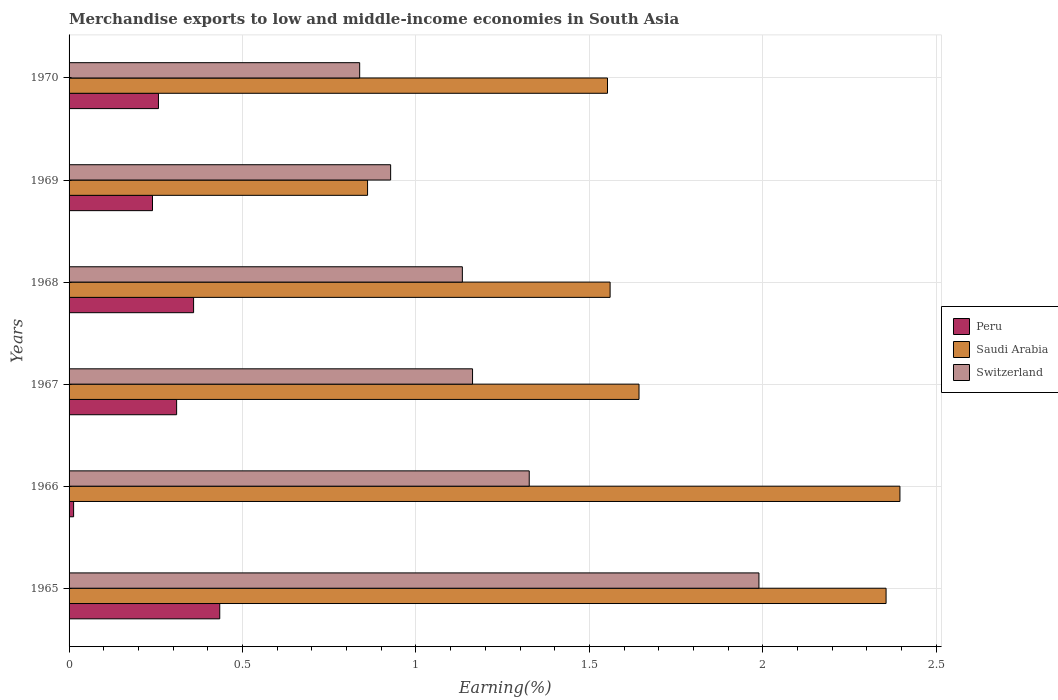How many groups of bars are there?
Make the answer very short. 6. How many bars are there on the 5th tick from the top?
Ensure brevity in your answer.  3. What is the label of the 2nd group of bars from the top?
Offer a terse response. 1969. What is the percentage of amount earned from merchandise exports in Switzerland in 1970?
Ensure brevity in your answer.  0.84. Across all years, what is the maximum percentage of amount earned from merchandise exports in Saudi Arabia?
Offer a terse response. 2.4. Across all years, what is the minimum percentage of amount earned from merchandise exports in Peru?
Your answer should be very brief. 0.01. In which year was the percentage of amount earned from merchandise exports in Peru maximum?
Your response must be concise. 1965. In which year was the percentage of amount earned from merchandise exports in Peru minimum?
Offer a very short reply. 1966. What is the total percentage of amount earned from merchandise exports in Saudi Arabia in the graph?
Make the answer very short. 10.37. What is the difference between the percentage of amount earned from merchandise exports in Peru in 1965 and that in 1969?
Provide a short and direct response. 0.19. What is the difference between the percentage of amount earned from merchandise exports in Peru in 1970 and the percentage of amount earned from merchandise exports in Saudi Arabia in 1967?
Offer a terse response. -1.39. What is the average percentage of amount earned from merchandise exports in Saudi Arabia per year?
Give a very brief answer. 1.73. In the year 1967, what is the difference between the percentage of amount earned from merchandise exports in Saudi Arabia and percentage of amount earned from merchandise exports in Peru?
Keep it short and to the point. 1.33. What is the ratio of the percentage of amount earned from merchandise exports in Switzerland in 1967 to that in 1969?
Offer a very short reply. 1.25. Is the difference between the percentage of amount earned from merchandise exports in Saudi Arabia in 1968 and 1970 greater than the difference between the percentage of amount earned from merchandise exports in Peru in 1968 and 1970?
Ensure brevity in your answer.  No. What is the difference between the highest and the second highest percentage of amount earned from merchandise exports in Switzerland?
Offer a very short reply. 0.66. What is the difference between the highest and the lowest percentage of amount earned from merchandise exports in Switzerland?
Provide a short and direct response. 1.15. Is the sum of the percentage of amount earned from merchandise exports in Switzerland in 1968 and 1969 greater than the maximum percentage of amount earned from merchandise exports in Peru across all years?
Ensure brevity in your answer.  Yes. What does the 3rd bar from the top in 1969 represents?
Your answer should be very brief. Peru. Are all the bars in the graph horizontal?
Keep it short and to the point. Yes. How many years are there in the graph?
Offer a terse response. 6. Are the values on the major ticks of X-axis written in scientific E-notation?
Offer a terse response. No. How many legend labels are there?
Your answer should be compact. 3. How are the legend labels stacked?
Make the answer very short. Vertical. What is the title of the graph?
Provide a short and direct response. Merchandise exports to low and middle-income economies in South Asia. What is the label or title of the X-axis?
Give a very brief answer. Earning(%). What is the Earning(%) of Peru in 1965?
Your answer should be very brief. 0.43. What is the Earning(%) in Saudi Arabia in 1965?
Offer a very short reply. 2.36. What is the Earning(%) in Switzerland in 1965?
Make the answer very short. 1.99. What is the Earning(%) in Peru in 1966?
Provide a succinct answer. 0.01. What is the Earning(%) in Saudi Arabia in 1966?
Provide a succinct answer. 2.4. What is the Earning(%) in Switzerland in 1966?
Ensure brevity in your answer.  1.33. What is the Earning(%) of Peru in 1967?
Offer a very short reply. 0.31. What is the Earning(%) of Saudi Arabia in 1967?
Make the answer very short. 1.64. What is the Earning(%) of Switzerland in 1967?
Keep it short and to the point. 1.16. What is the Earning(%) of Peru in 1968?
Give a very brief answer. 0.36. What is the Earning(%) in Saudi Arabia in 1968?
Provide a short and direct response. 1.56. What is the Earning(%) of Switzerland in 1968?
Offer a very short reply. 1.13. What is the Earning(%) of Peru in 1969?
Keep it short and to the point. 0.24. What is the Earning(%) of Saudi Arabia in 1969?
Your response must be concise. 0.86. What is the Earning(%) of Switzerland in 1969?
Give a very brief answer. 0.93. What is the Earning(%) in Peru in 1970?
Your answer should be very brief. 0.26. What is the Earning(%) of Saudi Arabia in 1970?
Your answer should be very brief. 1.55. What is the Earning(%) of Switzerland in 1970?
Give a very brief answer. 0.84. Across all years, what is the maximum Earning(%) of Peru?
Your answer should be very brief. 0.43. Across all years, what is the maximum Earning(%) in Saudi Arabia?
Offer a terse response. 2.4. Across all years, what is the maximum Earning(%) in Switzerland?
Give a very brief answer. 1.99. Across all years, what is the minimum Earning(%) of Peru?
Your answer should be compact. 0.01. Across all years, what is the minimum Earning(%) in Saudi Arabia?
Ensure brevity in your answer.  0.86. Across all years, what is the minimum Earning(%) of Switzerland?
Offer a very short reply. 0.84. What is the total Earning(%) in Peru in the graph?
Your answer should be very brief. 1.61. What is the total Earning(%) of Saudi Arabia in the graph?
Ensure brevity in your answer.  10.37. What is the total Earning(%) in Switzerland in the graph?
Provide a succinct answer. 7.38. What is the difference between the Earning(%) in Peru in 1965 and that in 1966?
Make the answer very short. 0.42. What is the difference between the Earning(%) in Saudi Arabia in 1965 and that in 1966?
Offer a terse response. -0.04. What is the difference between the Earning(%) of Switzerland in 1965 and that in 1966?
Your response must be concise. 0.66. What is the difference between the Earning(%) of Peru in 1965 and that in 1967?
Your response must be concise. 0.12. What is the difference between the Earning(%) of Saudi Arabia in 1965 and that in 1967?
Give a very brief answer. 0.71. What is the difference between the Earning(%) in Switzerland in 1965 and that in 1967?
Ensure brevity in your answer.  0.83. What is the difference between the Earning(%) of Peru in 1965 and that in 1968?
Provide a succinct answer. 0.08. What is the difference between the Earning(%) in Saudi Arabia in 1965 and that in 1968?
Offer a very short reply. 0.8. What is the difference between the Earning(%) in Switzerland in 1965 and that in 1968?
Your answer should be very brief. 0.85. What is the difference between the Earning(%) in Peru in 1965 and that in 1969?
Offer a terse response. 0.19. What is the difference between the Earning(%) of Saudi Arabia in 1965 and that in 1969?
Provide a short and direct response. 1.49. What is the difference between the Earning(%) of Switzerland in 1965 and that in 1969?
Make the answer very short. 1.06. What is the difference between the Earning(%) of Peru in 1965 and that in 1970?
Your answer should be compact. 0.18. What is the difference between the Earning(%) in Saudi Arabia in 1965 and that in 1970?
Make the answer very short. 0.8. What is the difference between the Earning(%) of Switzerland in 1965 and that in 1970?
Offer a terse response. 1.15. What is the difference between the Earning(%) in Peru in 1966 and that in 1967?
Ensure brevity in your answer.  -0.3. What is the difference between the Earning(%) in Saudi Arabia in 1966 and that in 1967?
Offer a terse response. 0.75. What is the difference between the Earning(%) in Switzerland in 1966 and that in 1967?
Offer a terse response. 0.16. What is the difference between the Earning(%) in Peru in 1966 and that in 1968?
Make the answer very short. -0.35. What is the difference between the Earning(%) in Saudi Arabia in 1966 and that in 1968?
Make the answer very short. 0.84. What is the difference between the Earning(%) in Switzerland in 1966 and that in 1968?
Provide a short and direct response. 0.19. What is the difference between the Earning(%) in Peru in 1966 and that in 1969?
Give a very brief answer. -0.23. What is the difference between the Earning(%) of Saudi Arabia in 1966 and that in 1969?
Offer a very short reply. 1.53. What is the difference between the Earning(%) in Switzerland in 1966 and that in 1969?
Give a very brief answer. 0.4. What is the difference between the Earning(%) in Peru in 1966 and that in 1970?
Offer a terse response. -0.24. What is the difference between the Earning(%) in Saudi Arabia in 1966 and that in 1970?
Make the answer very short. 0.84. What is the difference between the Earning(%) of Switzerland in 1966 and that in 1970?
Keep it short and to the point. 0.49. What is the difference between the Earning(%) of Peru in 1967 and that in 1968?
Your response must be concise. -0.05. What is the difference between the Earning(%) of Saudi Arabia in 1967 and that in 1968?
Provide a succinct answer. 0.08. What is the difference between the Earning(%) in Switzerland in 1967 and that in 1968?
Keep it short and to the point. 0.03. What is the difference between the Earning(%) of Peru in 1967 and that in 1969?
Your response must be concise. 0.07. What is the difference between the Earning(%) of Saudi Arabia in 1967 and that in 1969?
Offer a terse response. 0.78. What is the difference between the Earning(%) in Switzerland in 1967 and that in 1969?
Give a very brief answer. 0.24. What is the difference between the Earning(%) of Peru in 1967 and that in 1970?
Provide a succinct answer. 0.05. What is the difference between the Earning(%) in Saudi Arabia in 1967 and that in 1970?
Offer a very short reply. 0.09. What is the difference between the Earning(%) of Switzerland in 1967 and that in 1970?
Your answer should be very brief. 0.33. What is the difference between the Earning(%) in Peru in 1968 and that in 1969?
Provide a short and direct response. 0.12. What is the difference between the Earning(%) of Saudi Arabia in 1968 and that in 1969?
Your response must be concise. 0.7. What is the difference between the Earning(%) in Switzerland in 1968 and that in 1969?
Your response must be concise. 0.21. What is the difference between the Earning(%) in Peru in 1968 and that in 1970?
Provide a short and direct response. 0.1. What is the difference between the Earning(%) of Saudi Arabia in 1968 and that in 1970?
Make the answer very short. 0.01. What is the difference between the Earning(%) of Switzerland in 1968 and that in 1970?
Give a very brief answer. 0.3. What is the difference between the Earning(%) of Peru in 1969 and that in 1970?
Ensure brevity in your answer.  -0.02. What is the difference between the Earning(%) in Saudi Arabia in 1969 and that in 1970?
Provide a short and direct response. -0.69. What is the difference between the Earning(%) in Switzerland in 1969 and that in 1970?
Provide a short and direct response. 0.09. What is the difference between the Earning(%) in Peru in 1965 and the Earning(%) in Saudi Arabia in 1966?
Give a very brief answer. -1.96. What is the difference between the Earning(%) in Peru in 1965 and the Earning(%) in Switzerland in 1966?
Offer a terse response. -0.89. What is the difference between the Earning(%) of Saudi Arabia in 1965 and the Earning(%) of Switzerland in 1966?
Offer a very short reply. 1.03. What is the difference between the Earning(%) of Peru in 1965 and the Earning(%) of Saudi Arabia in 1967?
Make the answer very short. -1.21. What is the difference between the Earning(%) of Peru in 1965 and the Earning(%) of Switzerland in 1967?
Give a very brief answer. -0.73. What is the difference between the Earning(%) of Saudi Arabia in 1965 and the Earning(%) of Switzerland in 1967?
Make the answer very short. 1.19. What is the difference between the Earning(%) in Peru in 1965 and the Earning(%) in Saudi Arabia in 1968?
Your answer should be very brief. -1.13. What is the difference between the Earning(%) of Peru in 1965 and the Earning(%) of Switzerland in 1968?
Offer a very short reply. -0.7. What is the difference between the Earning(%) in Saudi Arabia in 1965 and the Earning(%) in Switzerland in 1968?
Offer a terse response. 1.22. What is the difference between the Earning(%) in Peru in 1965 and the Earning(%) in Saudi Arabia in 1969?
Keep it short and to the point. -0.43. What is the difference between the Earning(%) in Peru in 1965 and the Earning(%) in Switzerland in 1969?
Your response must be concise. -0.49. What is the difference between the Earning(%) in Saudi Arabia in 1965 and the Earning(%) in Switzerland in 1969?
Your response must be concise. 1.43. What is the difference between the Earning(%) in Peru in 1965 and the Earning(%) in Saudi Arabia in 1970?
Provide a short and direct response. -1.12. What is the difference between the Earning(%) in Peru in 1965 and the Earning(%) in Switzerland in 1970?
Give a very brief answer. -0.4. What is the difference between the Earning(%) of Saudi Arabia in 1965 and the Earning(%) of Switzerland in 1970?
Provide a short and direct response. 1.52. What is the difference between the Earning(%) of Peru in 1966 and the Earning(%) of Saudi Arabia in 1967?
Provide a short and direct response. -1.63. What is the difference between the Earning(%) in Peru in 1966 and the Earning(%) in Switzerland in 1967?
Make the answer very short. -1.15. What is the difference between the Earning(%) in Saudi Arabia in 1966 and the Earning(%) in Switzerland in 1967?
Your response must be concise. 1.23. What is the difference between the Earning(%) in Peru in 1966 and the Earning(%) in Saudi Arabia in 1968?
Offer a very short reply. -1.55. What is the difference between the Earning(%) in Peru in 1966 and the Earning(%) in Switzerland in 1968?
Provide a succinct answer. -1.12. What is the difference between the Earning(%) of Saudi Arabia in 1966 and the Earning(%) of Switzerland in 1968?
Offer a terse response. 1.26. What is the difference between the Earning(%) in Peru in 1966 and the Earning(%) in Saudi Arabia in 1969?
Offer a very short reply. -0.85. What is the difference between the Earning(%) in Peru in 1966 and the Earning(%) in Switzerland in 1969?
Offer a terse response. -0.91. What is the difference between the Earning(%) of Saudi Arabia in 1966 and the Earning(%) of Switzerland in 1969?
Give a very brief answer. 1.47. What is the difference between the Earning(%) of Peru in 1966 and the Earning(%) of Saudi Arabia in 1970?
Offer a terse response. -1.54. What is the difference between the Earning(%) in Peru in 1966 and the Earning(%) in Switzerland in 1970?
Ensure brevity in your answer.  -0.82. What is the difference between the Earning(%) in Saudi Arabia in 1966 and the Earning(%) in Switzerland in 1970?
Your response must be concise. 1.56. What is the difference between the Earning(%) of Peru in 1967 and the Earning(%) of Saudi Arabia in 1968?
Keep it short and to the point. -1.25. What is the difference between the Earning(%) in Peru in 1967 and the Earning(%) in Switzerland in 1968?
Your response must be concise. -0.82. What is the difference between the Earning(%) in Saudi Arabia in 1967 and the Earning(%) in Switzerland in 1968?
Provide a short and direct response. 0.51. What is the difference between the Earning(%) in Peru in 1967 and the Earning(%) in Saudi Arabia in 1969?
Provide a succinct answer. -0.55. What is the difference between the Earning(%) in Peru in 1967 and the Earning(%) in Switzerland in 1969?
Your answer should be very brief. -0.62. What is the difference between the Earning(%) in Saudi Arabia in 1967 and the Earning(%) in Switzerland in 1969?
Your answer should be very brief. 0.72. What is the difference between the Earning(%) in Peru in 1967 and the Earning(%) in Saudi Arabia in 1970?
Provide a succinct answer. -1.24. What is the difference between the Earning(%) of Peru in 1967 and the Earning(%) of Switzerland in 1970?
Give a very brief answer. -0.53. What is the difference between the Earning(%) in Saudi Arabia in 1967 and the Earning(%) in Switzerland in 1970?
Ensure brevity in your answer.  0.81. What is the difference between the Earning(%) in Peru in 1968 and the Earning(%) in Saudi Arabia in 1969?
Provide a succinct answer. -0.5. What is the difference between the Earning(%) of Peru in 1968 and the Earning(%) of Switzerland in 1969?
Your answer should be compact. -0.57. What is the difference between the Earning(%) of Saudi Arabia in 1968 and the Earning(%) of Switzerland in 1969?
Provide a short and direct response. 0.63. What is the difference between the Earning(%) in Peru in 1968 and the Earning(%) in Saudi Arabia in 1970?
Your answer should be compact. -1.19. What is the difference between the Earning(%) of Peru in 1968 and the Earning(%) of Switzerland in 1970?
Offer a very short reply. -0.48. What is the difference between the Earning(%) of Saudi Arabia in 1968 and the Earning(%) of Switzerland in 1970?
Ensure brevity in your answer.  0.72. What is the difference between the Earning(%) of Peru in 1969 and the Earning(%) of Saudi Arabia in 1970?
Your answer should be compact. -1.31. What is the difference between the Earning(%) of Peru in 1969 and the Earning(%) of Switzerland in 1970?
Provide a short and direct response. -0.6. What is the difference between the Earning(%) in Saudi Arabia in 1969 and the Earning(%) in Switzerland in 1970?
Offer a terse response. 0.02. What is the average Earning(%) of Peru per year?
Make the answer very short. 0.27. What is the average Earning(%) of Saudi Arabia per year?
Offer a very short reply. 1.73. What is the average Earning(%) in Switzerland per year?
Offer a very short reply. 1.23. In the year 1965, what is the difference between the Earning(%) of Peru and Earning(%) of Saudi Arabia?
Keep it short and to the point. -1.92. In the year 1965, what is the difference between the Earning(%) in Peru and Earning(%) in Switzerland?
Give a very brief answer. -1.55. In the year 1965, what is the difference between the Earning(%) of Saudi Arabia and Earning(%) of Switzerland?
Provide a short and direct response. 0.37. In the year 1966, what is the difference between the Earning(%) in Peru and Earning(%) in Saudi Arabia?
Make the answer very short. -2.38. In the year 1966, what is the difference between the Earning(%) in Peru and Earning(%) in Switzerland?
Make the answer very short. -1.31. In the year 1966, what is the difference between the Earning(%) in Saudi Arabia and Earning(%) in Switzerland?
Offer a terse response. 1.07. In the year 1967, what is the difference between the Earning(%) in Peru and Earning(%) in Saudi Arabia?
Give a very brief answer. -1.33. In the year 1967, what is the difference between the Earning(%) in Peru and Earning(%) in Switzerland?
Your answer should be compact. -0.85. In the year 1967, what is the difference between the Earning(%) of Saudi Arabia and Earning(%) of Switzerland?
Offer a terse response. 0.48. In the year 1968, what is the difference between the Earning(%) in Peru and Earning(%) in Saudi Arabia?
Make the answer very short. -1.2. In the year 1968, what is the difference between the Earning(%) in Peru and Earning(%) in Switzerland?
Ensure brevity in your answer.  -0.77. In the year 1968, what is the difference between the Earning(%) of Saudi Arabia and Earning(%) of Switzerland?
Provide a succinct answer. 0.43. In the year 1969, what is the difference between the Earning(%) of Peru and Earning(%) of Saudi Arabia?
Keep it short and to the point. -0.62. In the year 1969, what is the difference between the Earning(%) of Peru and Earning(%) of Switzerland?
Give a very brief answer. -0.69. In the year 1969, what is the difference between the Earning(%) of Saudi Arabia and Earning(%) of Switzerland?
Give a very brief answer. -0.07. In the year 1970, what is the difference between the Earning(%) of Peru and Earning(%) of Saudi Arabia?
Provide a succinct answer. -1.29. In the year 1970, what is the difference between the Earning(%) of Peru and Earning(%) of Switzerland?
Provide a short and direct response. -0.58. In the year 1970, what is the difference between the Earning(%) of Saudi Arabia and Earning(%) of Switzerland?
Provide a succinct answer. 0.71. What is the ratio of the Earning(%) in Peru in 1965 to that in 1966?
Ensure brevity in your answer.  33.25. What is the ratio of the Earning(%) of Saudi Arabia in 1965 to that in 1966?
Provide a succinct answer. 0.98. What is the ratio of the Earning(%) in Switzerland in 1965 to that in 1966?
Your answer should be compact. 1.5. What is the ratio of the Earning(%) in Peru in 1965 to that in 1967?
Your answer should be compact. 1.4. What is the ratio of the Earning(%) in Saudi Arabia in 1965 to that in 1967?
Give a very brief answer. 1.43. What is the ratio of the Earning(%) of Switzerland in 1965 to that in 1967?
Make the answer very short. 1.71. What is the ratio of the Earning(%) in Peru in 1965 to that in 1968?
Provide a succinct answer. 1.21. What is the ratio of the Earning(%) in Saudi Arabia in 1965 to that in 1968?
Your answer should be compact. 1.51. What is the ratio of the Earning(%) of Switzerland in 1965 to that in 1968?
Keep it short and to the point. 1.75. What is the ratio of the Earning(%) in Peru in 1965 to that in 1969?
Your answer should be compact. 1.81. What is the ratio of the Earning(%) of Saudi Arabia in 1965 to that in 1969?
Your response must be concise. 2.74. What is the ratio of the Earning(%) of Switzerland in 1965 to that in 1969?
Offer a very short reply. 2.15. What is the ratio of the Earning(%) in Peru in 1965 to that in 1970?
Give a very brief answer. 1.69. What is the ratio of the Earning(%) of Saudi Arabia in 1965 to that in 1970?
Provide a short and direct response. 1.52. What is the ratio of the Earning(%) of Switzerland in 1965 to that in 1970?
Your answer should be very brief. 2.37. What is the ratio of the Earning(%) in Peru in 1966 to that in 1967?
Your answer should be very brief. 0.04. What is the ratio of the Earning(%) in Saudi Arabia in 1966 to that in 1967?
Offer a very short reply. 1.46. What is the ratio of the Earning(%) in Switzerland in 1966 to that in 1967?
Provide a succinct answer. 1.14. What is the ratio of the Earning(%) in Peru in 1966 to that in 1968?
Provide a succinct answer. 0.04. What is the ratio of the Earning(%) of Saudi Arabia in 1966 to that in 1968?
Provide a short and direct response. 1.54. What is the ratio of the Earning(%) of Switzerland in 1966 to that in 1968?
Offer a terse response. 1.17. What is the ratio of the Earning(%) of Peru in 1966 to that in 1969?
Offer a terse response. 0.05. What is the ratio of the Earning(%) in Saudi Arabia in 1966 to that in 1969?
Offer a very short reply. 2.78. What is the ratio of the Earning(%) in Switzerland in 1966 to that in 1969?
Provide a succinct answer. 1.43. What is the ratio of the Earning(%) of Peru in 1966 to that in 1970?
Provide a succinct answer. 0.05. What is the ratio of the Earning(%) in Saudi Arabia in 1966 to that in 1970?
Your response must be concise. 1.54. What is the ratio of the Earning(%) of Switzerland in 1966 to that in 1970?
Your answer should be very brief. 1.58. What is the ratio of the Earning(%) of Peru in 1967 to that in 1968?
Offer a very short reply. 0.86. What is the ratio of the Earning(%) of Saudi Arabia in 1967 to that in 1968?
Keep it short and to the point. 1.05. What is the ratio of the Earning(%) in Switzerland in 1967 to that in 1968?
Give a very brief answer. 1.03. What is the ratio of the Earning(%) in Peru in 1967 to that in 1969?
Give a very brief answer. 1.29. What is the ratio of the Earning(%) in Saudi Arabia in 1967 to that in 1969?
Keep it short and to the point. 1.91. What is the ratio of the Earning(%) of Switzerland in 1967 to that in 1969?
Your response must be concise. 1.25. What is the ratio of the Earning(%) of Peru in 1967 to that in 1970?
Keep it short and to the point. 1.2. What is the ratio of the Earning(%) of Saudi Arabia in 1967 to that in 1970?
Your answer should be very brief. 1.06. What is the ratio of the Earning(%) in Switzerland in 1967 to that in 1970?
Ensure brevity in your answer.  1.39. What is the ratio of the Earning(%) in Peru in 1968 to that in 1969?
Your answer should be very brief. 1.49. What is the ratio of the Earning(%) of Saudi Arabia in 1968 to that in 1969?
Ensure brevity in your answer.  1.81. What is the ratio of the Earning(%) in Switzerland in 1968 to that in 1969?
Ensure brevity in your answer.  1.22. What is the ratio of the Earning(%) in Peru in 1968 to that in 1970?
Your answer should be compact. 1.39. What is the ratio of the Earning(%) of Saudi Arabia in 1968 to that in 1970?
Give a very brief answer. 1. What is the ratio of the Earning(%) in Switzerland in 1968 to that in 1970?
Make the answer very short. 1.35. What is the ratio of the Earning(%) in Peru in 1969 to that in 1970?
Offer a very short reply. 0.93. What is the ratio of the Earning(%) in Saudi Arabia in 1969 to that in 1970?
Provide a succinct answer. 0.55. What is the ratio of the Earning(%) of Switzerland in 1969 to that in 1970?
Offer a very short reply. 1.11. What is the difference between the highest and the second highest Earning(%) in Peru?
Keep it short and to the point. 0.08. What is the difference between the highest and the second highest Earning(%) of Saudi Arabia?
Offer a terse response. 0.04. What is the difference between the highest and the second highest Earning(%) in Switzerland?
Ensure brevity in your answer.  0.66. What is the difference between the highest and the lowest Earning(%) of Peru?
Your response must be concise. 0.42. What is the difference between the highest and the lowest Earning(%) of Saudi Arabia?
Provide a short and direct response. 1.53. What is the difference between the highest and the lowest Earning(%) in Switzerland?
Offer a terse response. 1.15. 